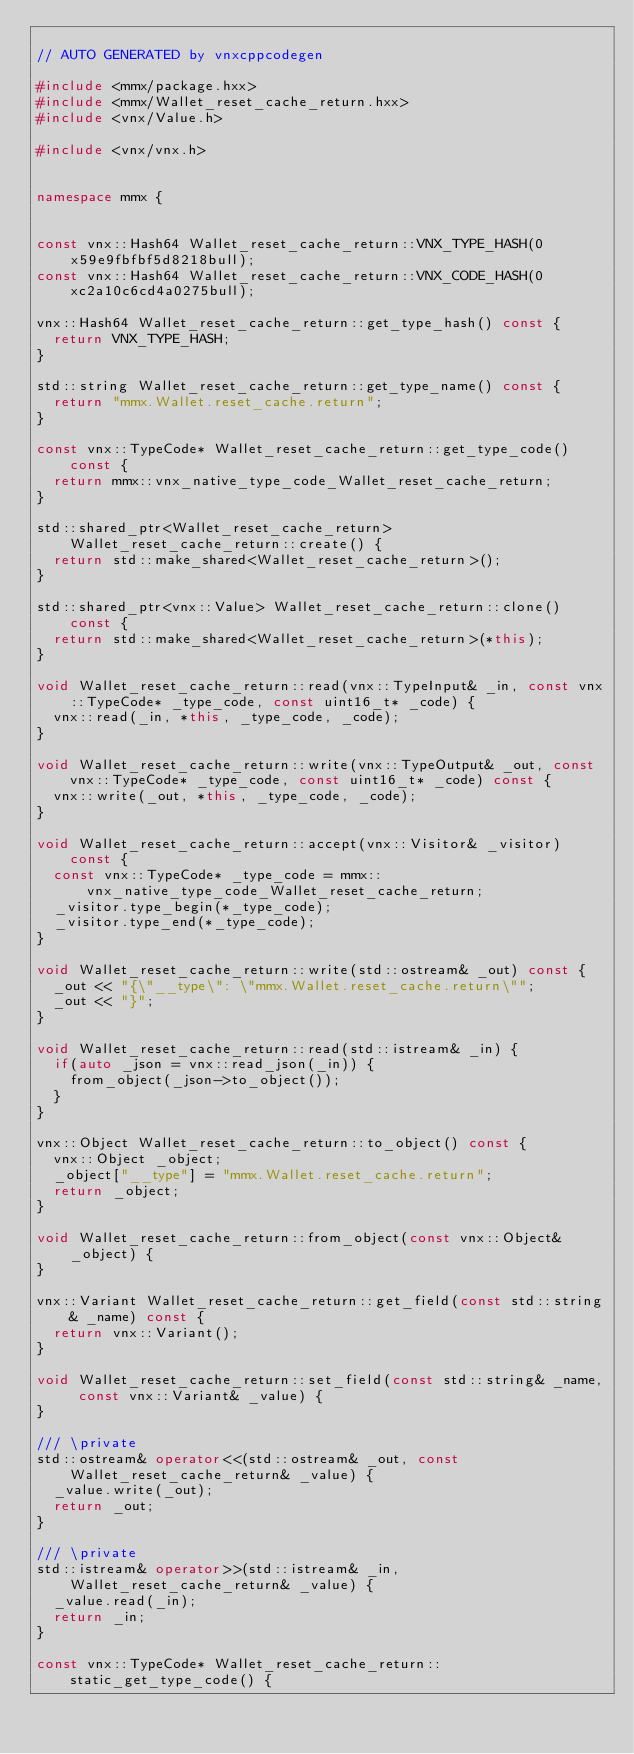<code> <loc_0><loc_0><loc_500><loc_500><_C++_>
// AUTO GENERATED by vnxcppcodegen

#include <mmx/package.hxx>
#include <mmx/Wallet_reset_cache_return.hxx>
#include <vnx/Value.h>

#include <vnx/vnx.h>


namespace mmx {


const vnx::Hash64 Wallet_reset_cache_return::VNX_TYPE_HASH(0x59e9fbfbf5d8218bull);
const vnx::Hash64 Wallet_reset_cache_return::VNX_CODE_HASH(0xc2a10c6cd4a0275bull);

vnx::Hash64 Wallet_reset_cache_return::get_type_hash() const {
	return VNX_TYPE_HASH;
}

std::string Wallet_reset_cache_return::get_type_name() const {
	return "mmx.Wallet.reset_cache.return";
}

const vnx::TypeCode* Wallet_reset_cache_return::get_type_code() const {
	return mmx::vnx_native_type_code_Wallet_reset_cache_return;
}

std::shared_ptr<Wallet_reset_cache_return> Wallet_reset_cache_return::create() {
	return std::make_shared<Wallet_reset_cache_return>();
}

std::shared_ptr<vnx::Value> Wallet_reset_cache_return::clone() const {
	return std::make_shared<Wallet_reset_cache_return>(*this);
}

void Wallet_reset_cache_return::read(vnx::TypeInput& _in, const vnx::TypeCode* _type_code, const uint16_t* _code) {
	vnx::read(_in, *this, _type_code, _code);
}

void Wallet_reset_cache_return::write(vnx::TypeOutput& _out, const vnx::TypeCode* _type_code, const uint16_t* _code) const {
	vnx::write(_out, *this, _type_code, _code);
}

void Wallet_reset_cache_return::accept(vnx::Visitor& _visitor) const {
	const vnx::TypeCode* _type_code = mmx::vnx_native_type_code_Wallet_reset_cache_return;
	_visitor.type_begin(*_type_code);
	_visitor.type_end(*_type_code);
}

void Wallet_reset_cache_return::write(std::ostream& _out) const {
	_out << "{\"__type\": \"mmx.Wallet.reset_cache.return\"";
	_out << "}";
}

void Wallet_reset_cache_return::read(std::istream& _in) {
	if(auto _json = vnx::read_json(_in)) {
		from_object(_json->to_object());
	}
}

vnx::Object Wallet_reset_cache_return::to_object() const {
	vnx::Object _object;
	_object["__type"] = "mmx.Wallet.reset_cache.return";
	return _object;
}

void Wallet_reset_cache_return::from_object(const vnx::Object& _object) {
}

vnx::Variant Wallet_reset_cache_return::get_field(const std::string& _name) const {
	return vnx::Variant();
}

void Wallet_reset_cache_return::set_field(const std::string& _name, const vnx::Variant& _value) {
}

/// \private
std::ostream& operator<<(std::ostream& _out, const Wallet_reset_cache_return& _value) {
	_value.write(_out);
	return _out;
}

/// \private
std::istream& operator>>(std::istream& _in, Wallet_reset_cache_return& _value) {
	_value.read(_in);
	return _in;
}

const vnx::TypeCode* Wallet_reset_cache_return::static_get_type_code() {</code> 